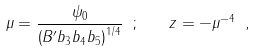Convert formula to latex. <formula><loc_0><loc_0><loc_500><loc_500>\mu = \frac { \psi _ { 0 } } { \left ( B ^ { \prime } b _ { 3 } b _ { 4 } b _ { 5 } \right ) ^ { 1 / 4 } } \ ; \quad z = - \mu ^ { - 4 } \ ,</formula> 